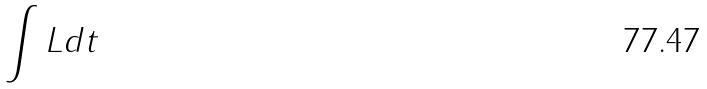Convert formula to latex. <formula><loc_0><loc_0><loc_500><loc_500>\int L d t</formula> 